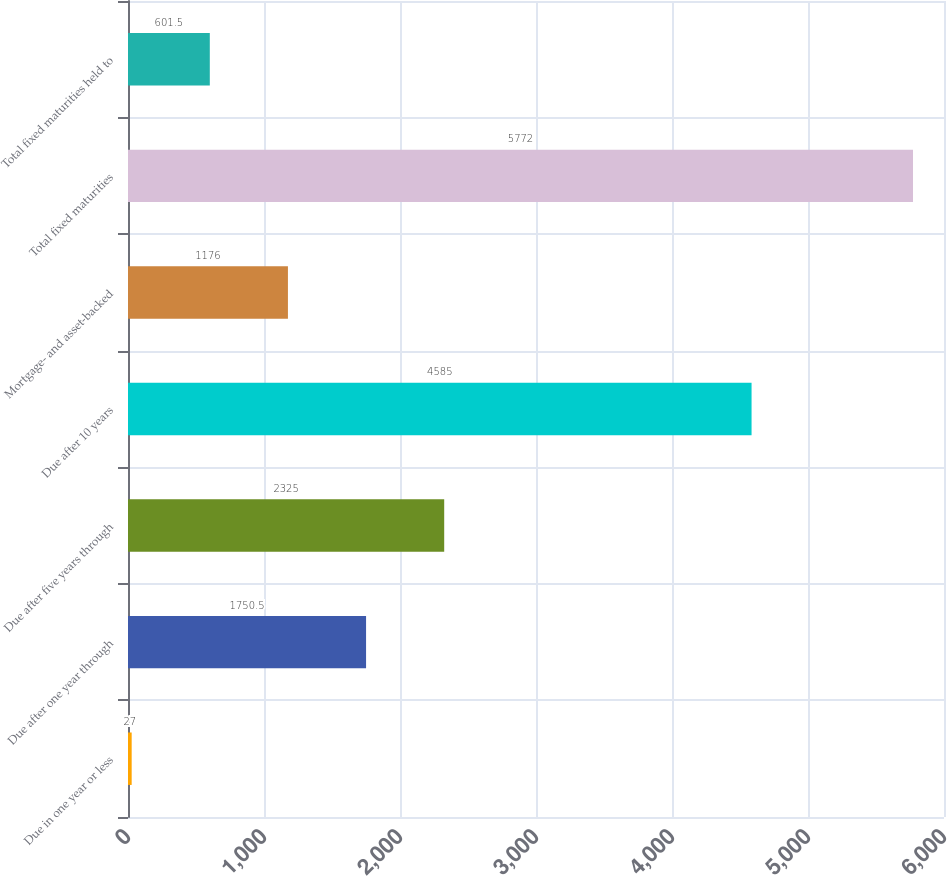Convert chart to OTSL. <chart><loc_0><loc_0><loc_500><loc_500><bar_chart><fcel>Due in one year or less<fcel>Due after one year through<fcel>Due after five years through<fcel>Due after 10 years<fcel>Mortgage- and asset-backed<fcel>Total fixed maturities<fcel>Total fixed maturities held to<nl><fcel>27<fcel>1750.5<fcel>2325<fcel>4585<fcel>1176<fcel>5772<fcel>601.5<nl></chart> 